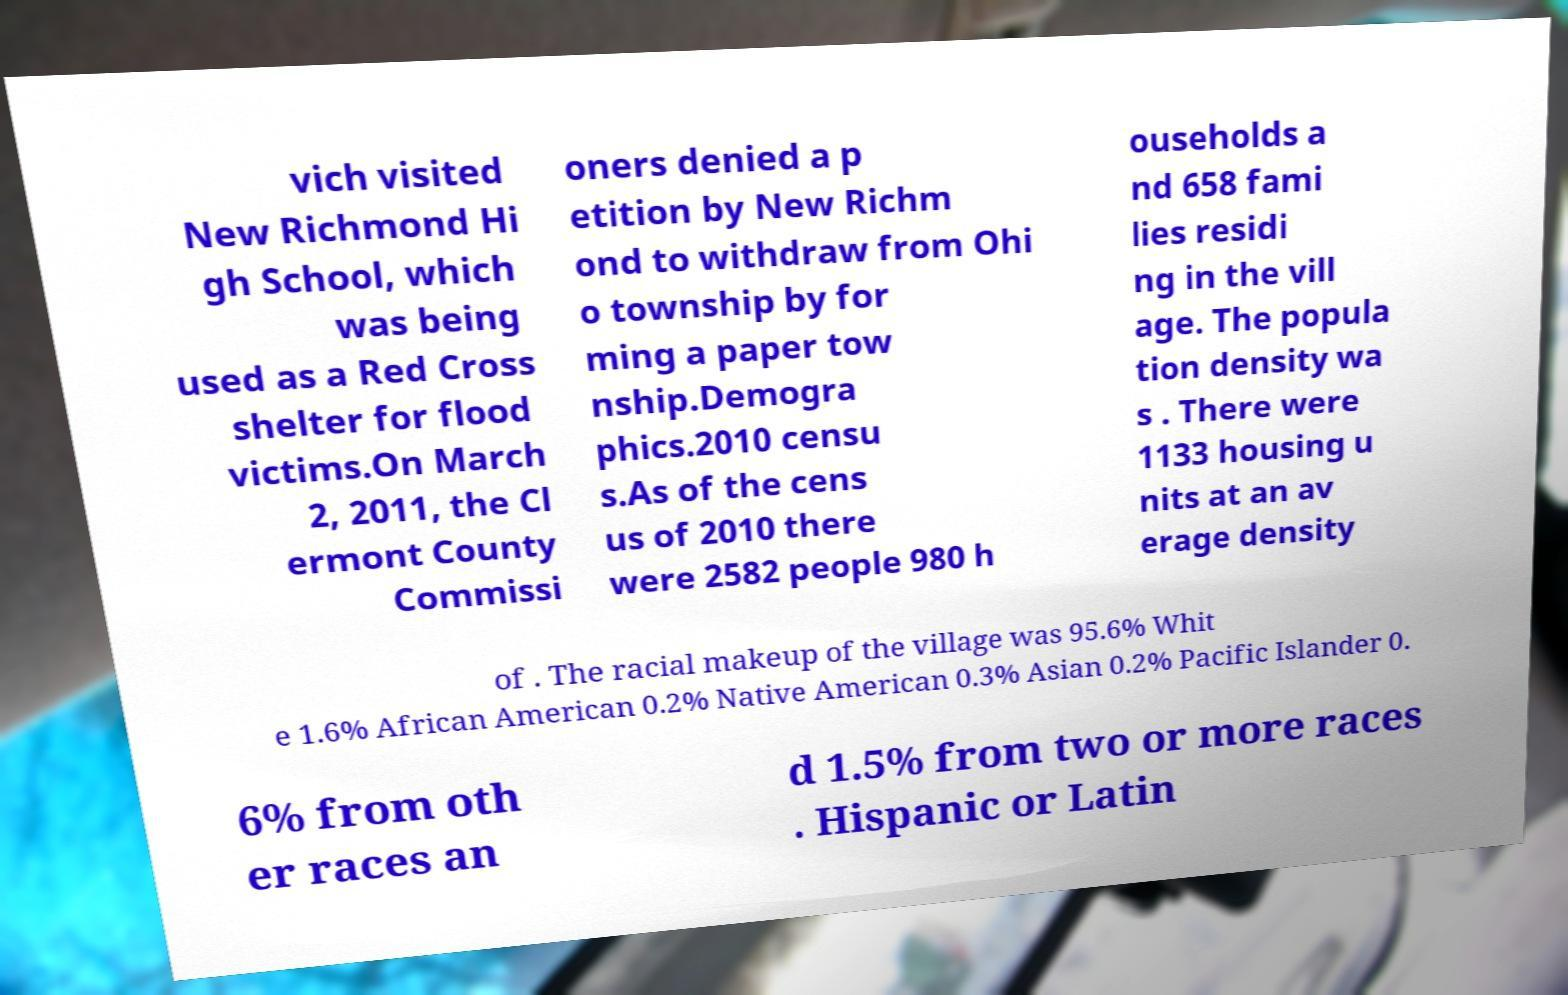Can you read and provide the text displayed in the image?This photo seems to have some interesting text. Can you extract and type it out for me? vich visited New Richmond Hi gh School, which was being used as a Red Cross shelter for flood victims.On March 2, 2011, the Cl ermont County Commissi oners denied a p etition by New Richm ond to withdraw from Ohi o township by for ming a paper tow nship.Demogra phics.2010 censu s.As of the cens us of 2010 there were 2582 people 980 h ouseholds a nd 658 fami lies residi ng in the vill age. The popula tion density wa s . There were 1133 housing u nits at an av erage density of . The racial makeup of the village was 95.6% Whit e 1.6% African American 0.2% Native American 0.3% Asian 0.2% Pacific Islander 0. 6% from oth er races an d 1.5% from two or more races . Hispanic or Latin 